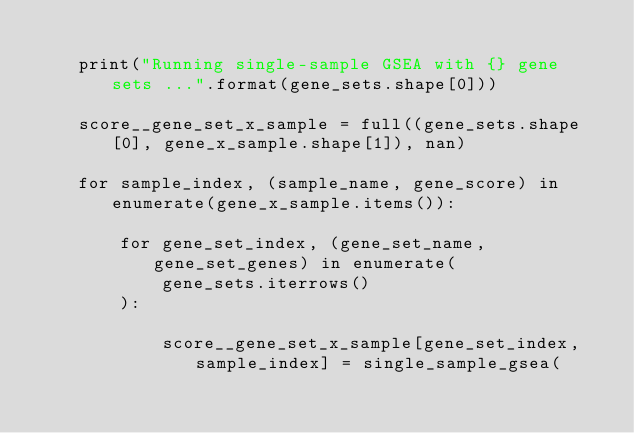Convert code to text. <code><loc_0><loc_0><loc_500><loc_500><_Python_>
    print("Running single-sample GSEA with {} gene sets ...".format(gene_sets.shape[0]))

    score__gene_set_x_sample = full((gene_sets.shape[0], gene_x_sample.shape[1]), nan)

    for sample_index, (sample_name, gene_score) in enumerate(gene_x_sample.items()):

        for gene_set_index, (gene_set_name, gene_set_genes) in enumerate(
            gene_sets.iterrows()
        ):

            score__gene_set_x_sample[gene_set_index, sample_index] = single_sample_gsea(</code> 